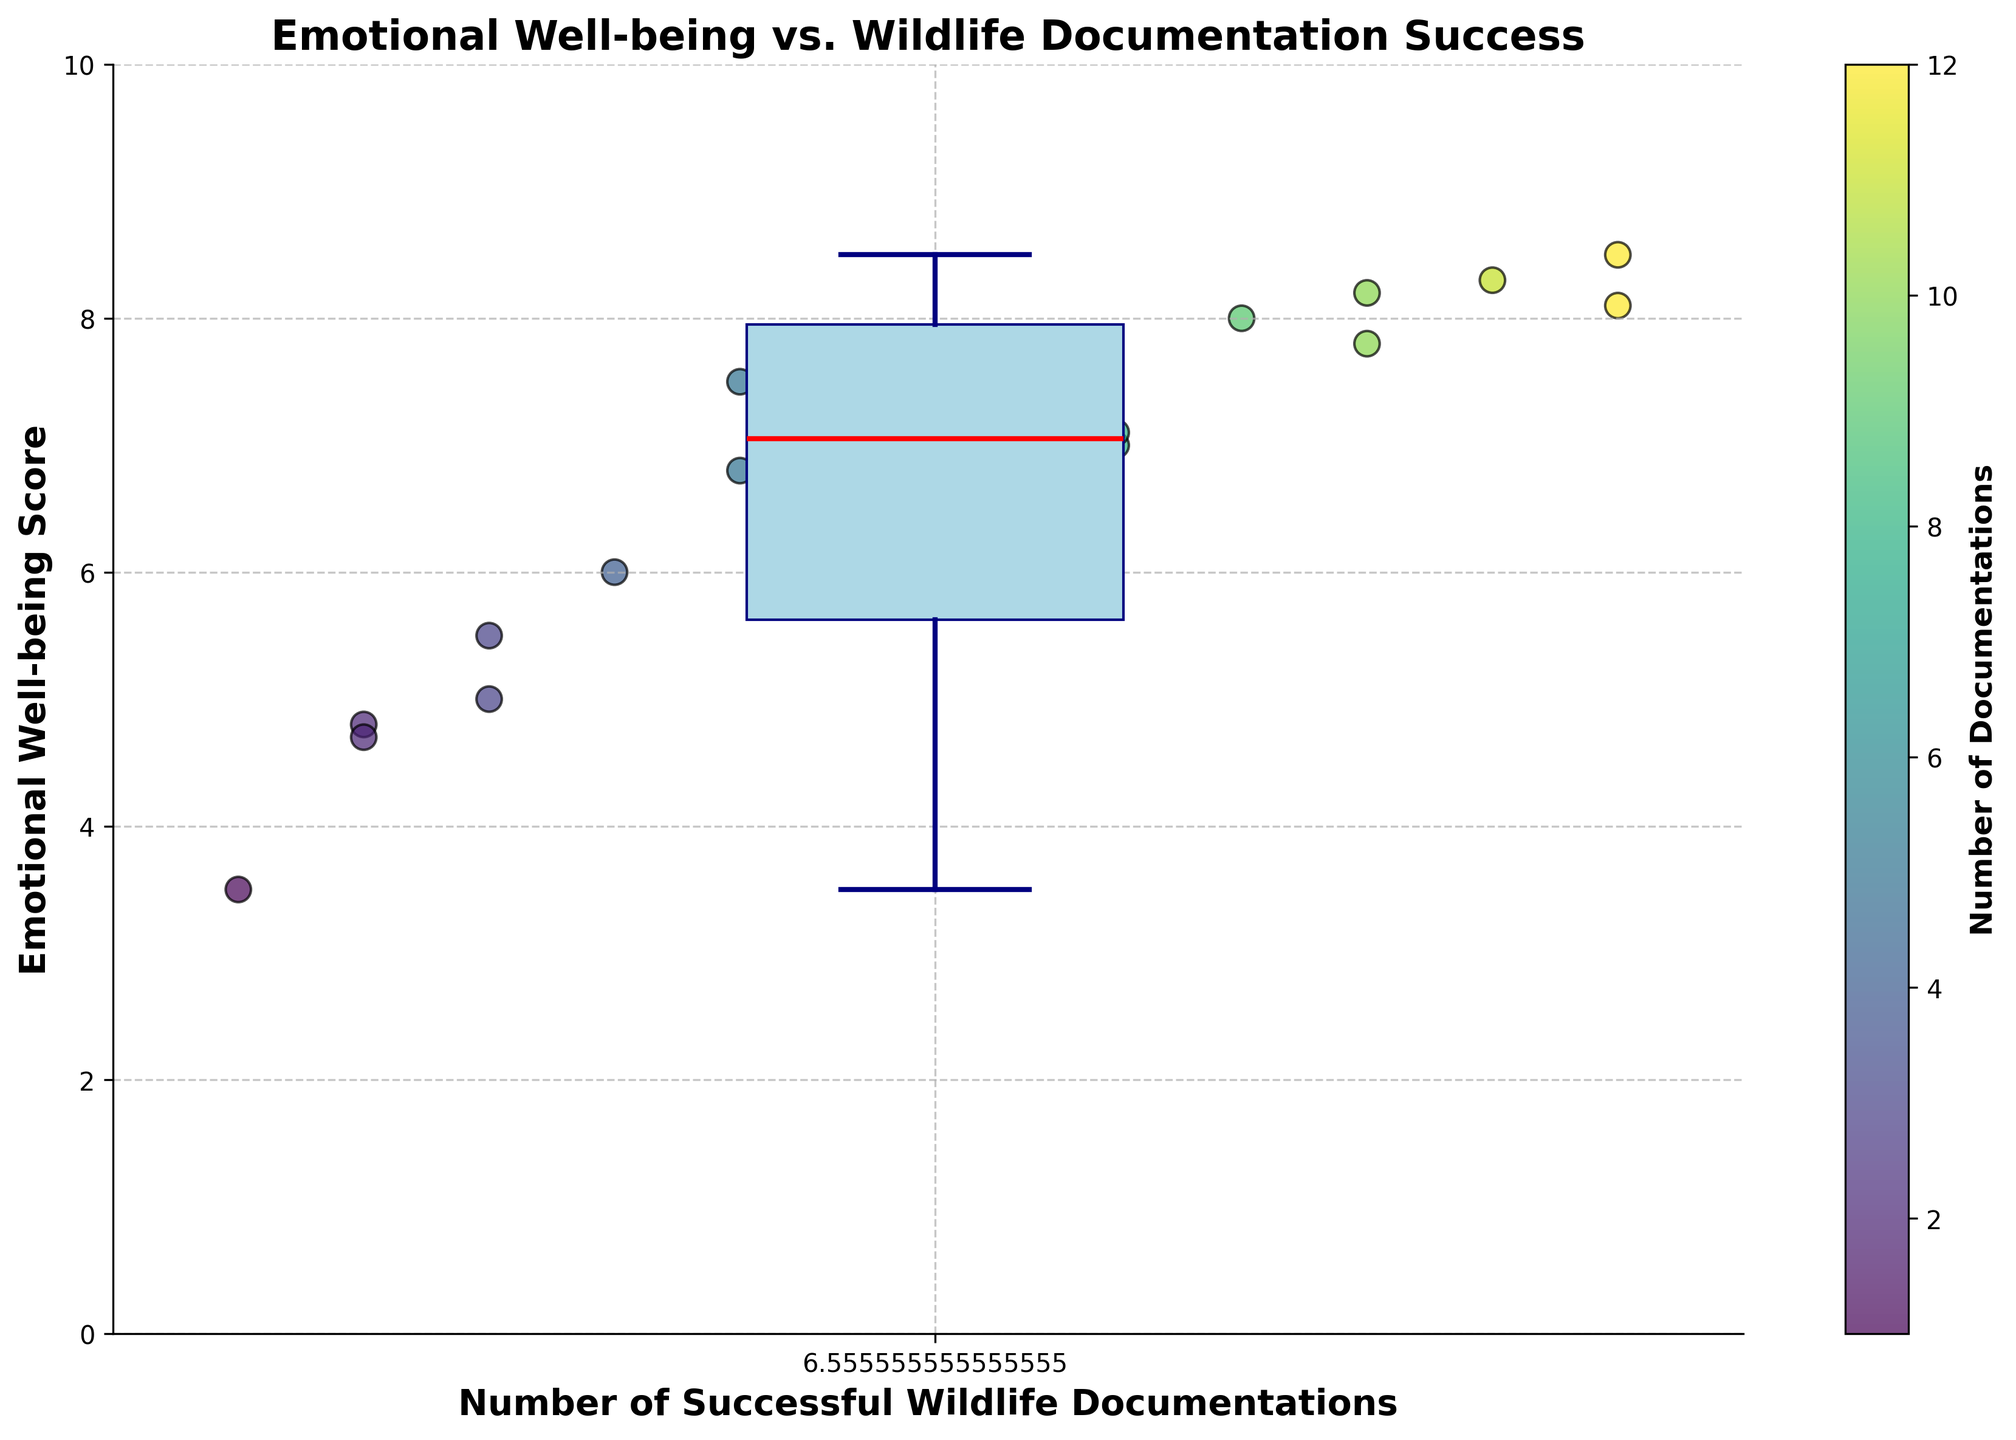What's the title of the plot? The title is located at the top of the plot and clearly states the purpose of the figure.
Answer: Emotional Well-being vs. Wildlife Documentation Success Which axis represents the Emotional Well-being Score? The y-axis label indicates that it represents the Emotional Well-being Score.
Answer: y-axis What's the median Emotional Well-being Score based on the box plot? The median value is shown as a red line within the box of the box plot.
Answer: Approximately 7.1 How many divers have documented 12 successful wildlife observations? The scatter points along the x-axis can be counted to determine this.
Answer: 2 divers Who has the lowest Emotional Well-being Score and what is it? The scatter point at the lowest position on the y-axis represents the lowest Emotional Well-being Score. This point corresponds to Dwight Schrute with a score of 3.5.
Answer: Dwight Schrute, 3.5 Is there a positive correlation between the number of successful wildlife documentations and Emotional Well-being Score? By visually assessing the scatter plot, one can see that as the number of successful documentations increases, so does the Emotional Well-being Score, indicating a positive correlation.
Answer: Yes What is the range of the Emotional Well-being Scores in the plot? The range can be determined by identifying the maximum and minimum values on the y-axis. The highest score is about 8.5 and the lowest is 3.5. Calculating the difference, 8.5 - 3.5 = 5.
Answer: 5 Which documentation count has the highest Emotional Well-being Score, and what is the score? By looking at the scatter points, the highest score aligns with 12 documentations and a score of 8.5 seen from Rachel Green's data point.
Answer: 12 documentations, 8.5 Who has the median documentation count, and what's their Emotional Well-being Score? To find the median documentation count, list all documentation counts and find the middle value. With 19 data points, the 10th value in sorted order is the median. Michael Lee, who has documented 7 times, falls into the middle. His Emotional Well-being Score is 6.9.
Answer: Michael Lee, 6.9 